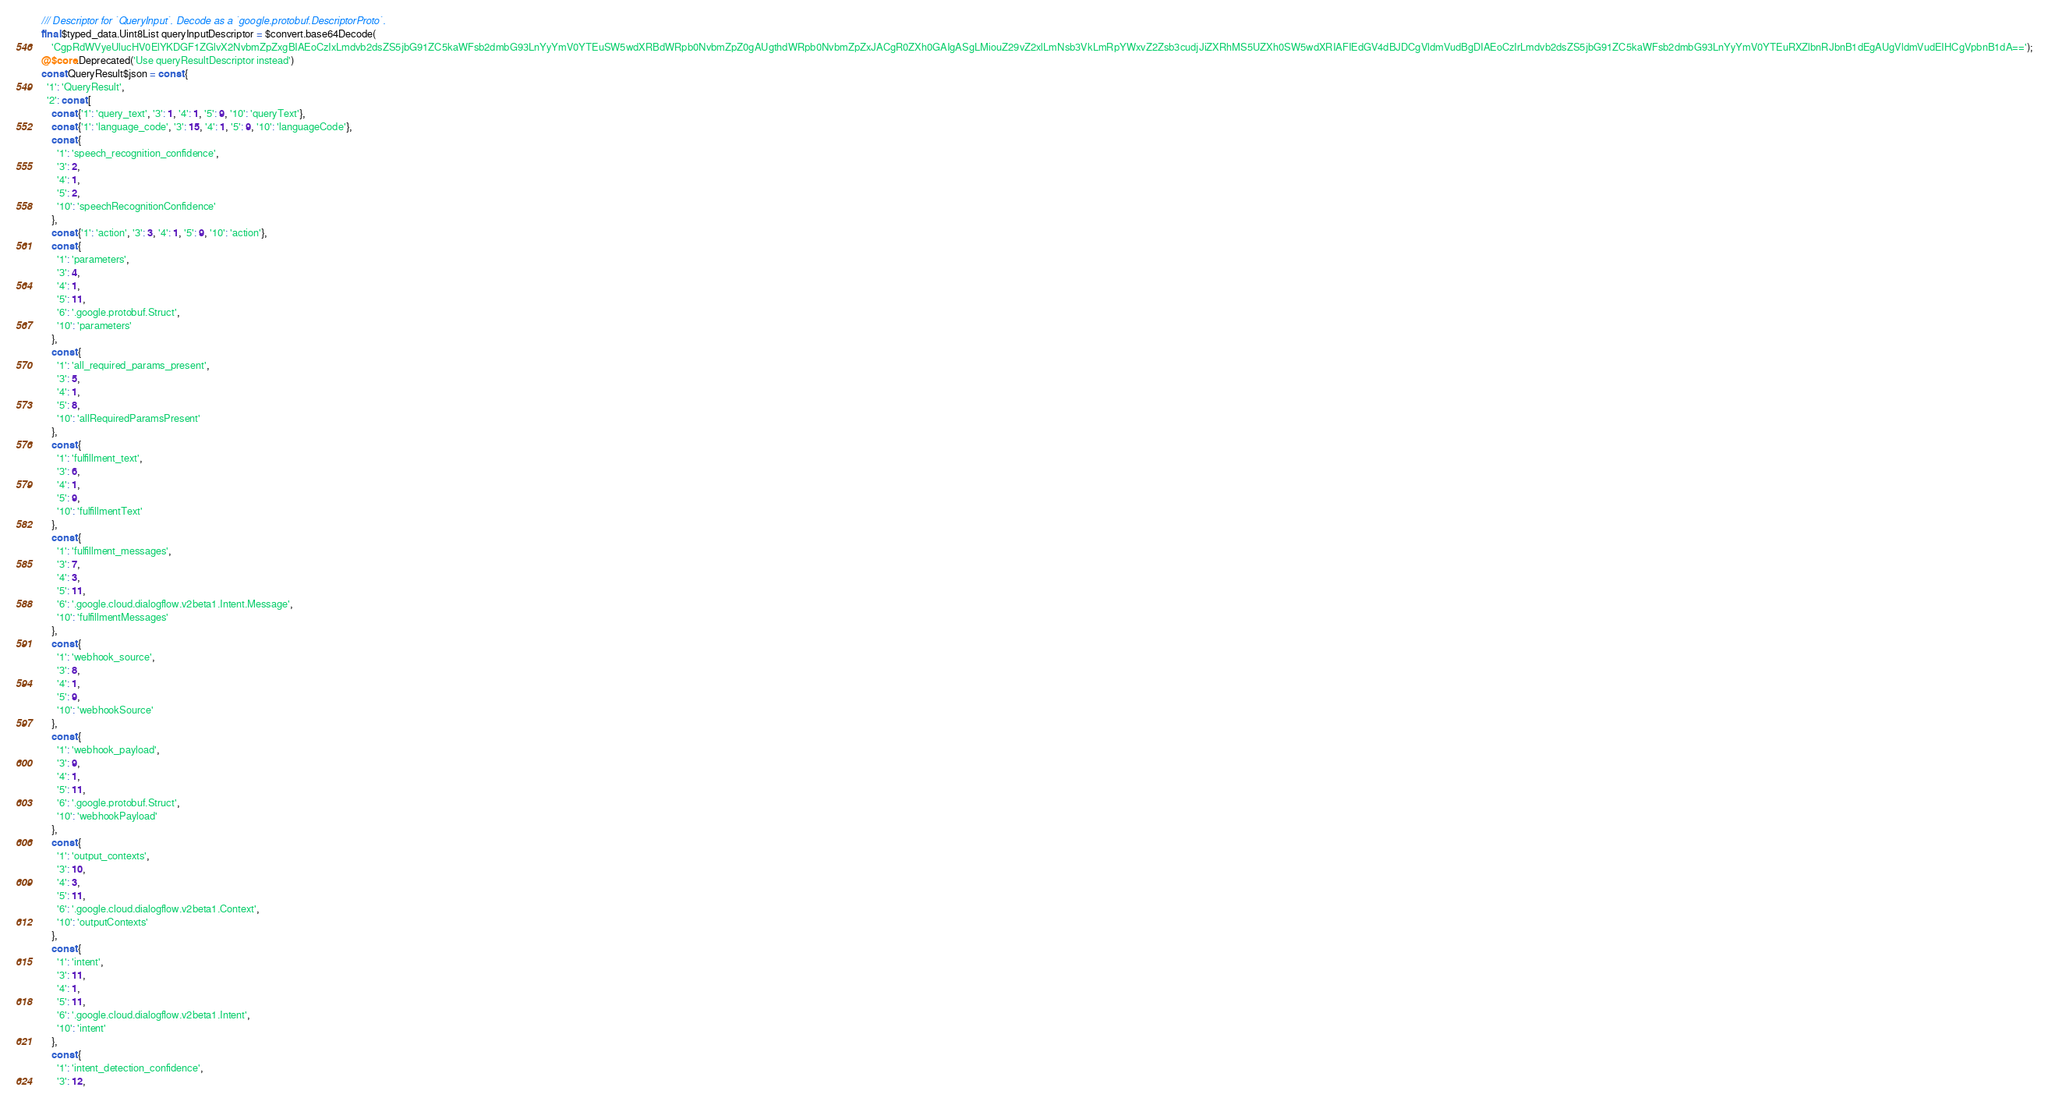Convert code to text. <code><loc_0><loc_0><loc_500><loc_500><_Dart_>/// Descriptor for `QueryInput`. Decode as a `google.protobuf.DescriptorProto`.
final $typed_data.Uint8List queryInputDescriptor = $convert.base64Decode(
    'CgpRdWVyeUlucHV0ElYKDGF1ZGlvX2NvbmZpZxgBIAEoCzIxLmdvb2dsZS5jbG91ZC5kaWFsb2dmbG93LnYyYmV0YTEuSW5wdXRBdWRpb0NvbmZpZ0gAUgthdWRpb0NvbmZpZxJACgR0ZXh0GAIgASgLMiouZ29vZ2xlLmNsb3VkLmRpYWxvZ2Zsb3cudjJiZXRhMS5UZXh0SW5wdXRIAFIEdGV4dBJDCgVldmVudBgDIAEoCzIrLmdvb2dsZS5jbG91ZC5kaWFsb2dmbG93LnYyYmV0YTEuRXZlbnRJbnB1dEgAUgVldmVudEIHCgVpbnB1dA==');
@$core.Deprecated('Use queryResultDescriptor instead')
const QueryResult$json = const {
  '1': 'QueryResult',
  '2': const [
    const {'1': 'query_text', '3': 1, '4': 1, '5': 9, '10': 'queryText'},
    const {'1': 'language_code', '3': 15, '4': 1, '5': 9, '10': 'languageCode'},
    const {
      '1': 'speech_recognition_confidence',
      '3': 2,
      '4': 1,
      '5': 2,
      '10': 'speechRecognitionConfidence'
    },
    const {'1': 'action', '3': 3, '4': 1, '5': 9, '10': 'action'},
    const {
      '1': 'parameters',
      '3': 4,
      '4': 1,
      '5': 11,
      '6': '.google.protobuf.Struct',
      '10': 'parameters'
    },
    const {
      '1': 'all_required_params_present',
      '3': 5,
      '4': 1,
      '5': 8,
      '10': 'allRequiredParamsPresent'
    },
    const {
      '1': 'fulfillment_text',
      '3': 6,
      '4': 1,
      '5': 9,
      '10': 'fulfillmentText'
    },
    const {
      '1': 'fulfillment_messages',
      '3': 7,
      '4': 3,
      '5': 11,
      '6': '.google.cloud.dialogflow.v2beta1.Intent.Message',
      '10': 'fulfillmentMessages'
    },
    const {
      '1': 'webhook_source',
      '3': 8,
      '4': 1,
      '5': 9,
      '10': 'webhookSource'
    },
    const {
      '1': 'webhook_payload',
      '3': 9,
      '4': 1,
      '5': 11,
      '6': '.google.protobuf.Struct',
      '10': 'webhookPayload'
    },
    const {
      '1': 'output_contexts',
      '3': 10,
      '4': 3,
      '5': 11,
      '6': '.google.cloud.dialogflow.v2beta1.Context',
      '10': 'outputContexts'
    },
    const {
      '1': 'intent',
      '3': 11,
      '4': 1,
      '5': 11,
      '6': '.google.cloud.dialogflow.v2beta1.Intent',
      '10': 'intent'
    },
    const {
      '1': 'intent_detection_confidence',
      '3': 12,</code> 